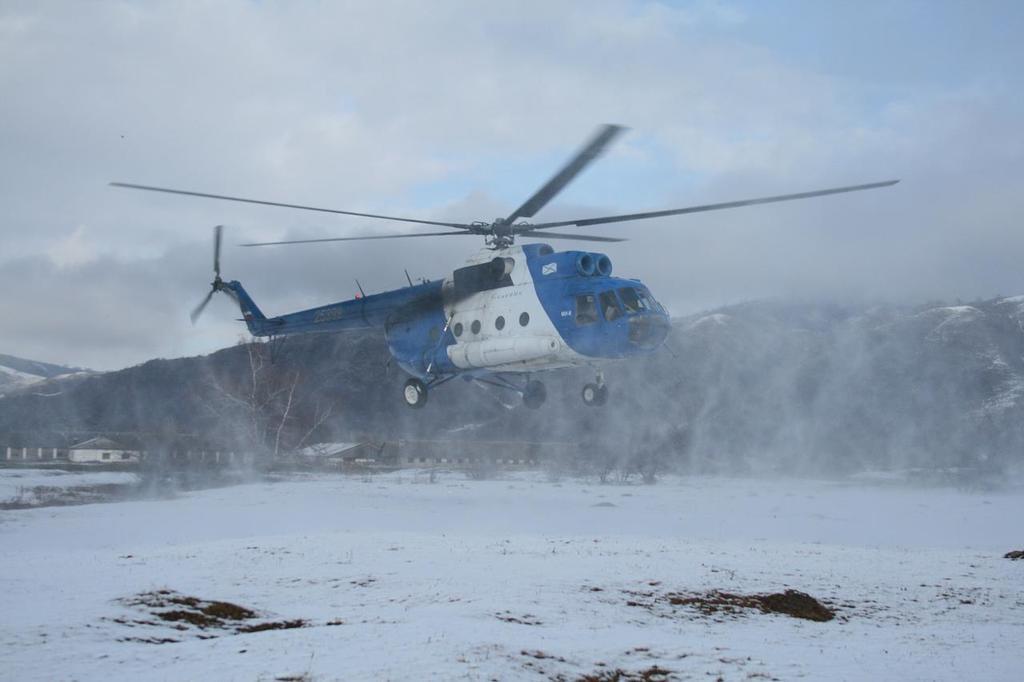Please provide a concise description of this image. In this image I see a helicopter which is of white and blue in color and I see the white snow. In the background I see the mountains and the sky and I see the smoke over here. I can also see a house over here. 